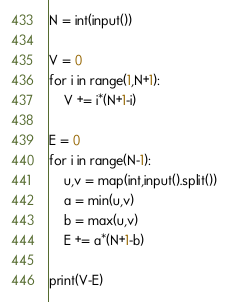<code> <loc_0><loc_0><loc_500><loc_500><_Python_>N = int(input())

V = 0
for i in range(1,N+1):
    V += i*(N+1-i)

E = 0
for i in range(N-1):
    u,v = map(int,input().split())
    a = min(u,v)
    b = max(u,v)
    E += a*(N+1-b)

print(V-E)</code> 